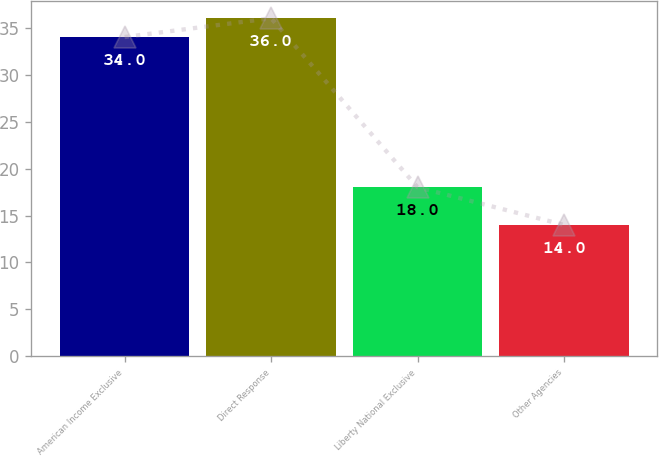Convert chart. <chart><loc_0><loc_0><loc_500><loc_500><bar_chart><fcel>American Income Exclusive<fcel>Direct Response<fcel>Liberty National Exclusive<fcel>Other Agencies<nl><fcel>34<fcel>36<fcel>18<fcel>14<nl></chart> 